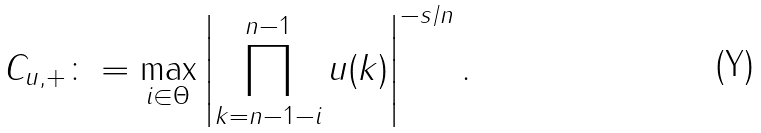Convert formula to latex. <formula><loc_0><loc_0><loc_500><loc_500>C _ { u , + } \colon = \max _ { i \in \Theta } \left | \prod _ { k = n - 1 - i } ^ { n - 1 } u ( k ) \right | ^ { - s / n } .</formula> 